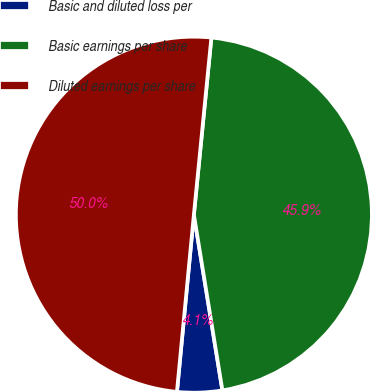Convert chart to OTSL. <chart><loc_0><loc_0><loc_500><loc_500><pie_chart><fcel>Basic and diluted loss per<fcel>Basic earnings per share<fcel>Diluted earnings per share<nl><fcel>4.08%<fcel>45.87%<fcel>50.05%<nl></chart> 